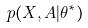<formula> <loc_0><loc_0><loc_500><loc_500>p ( X , A | \theta ^ { * } )</formula> 